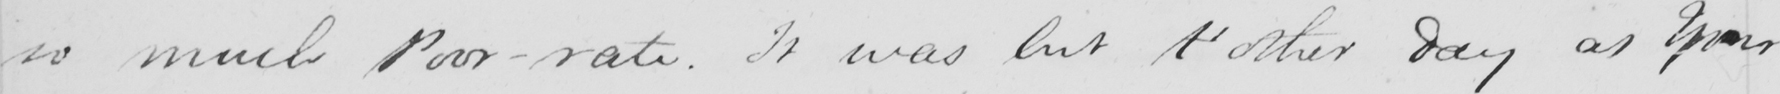Can you tell me what this handwritten text says? so much Poor-rate . It was but t ' other day as Your 